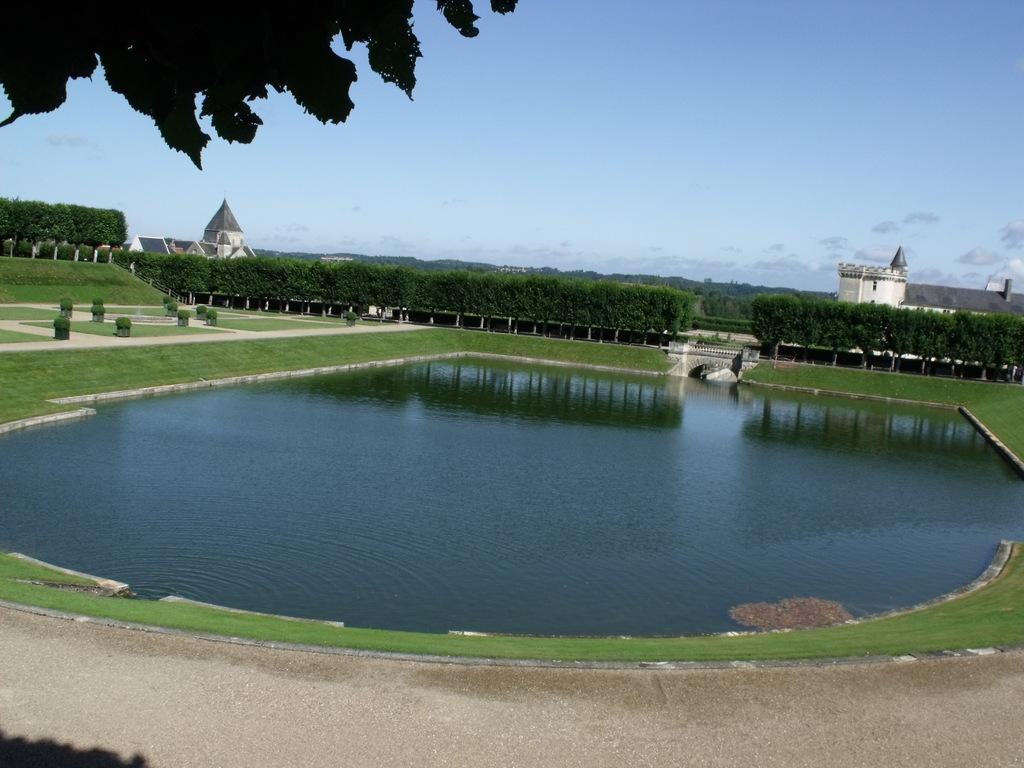What type of outdoor space is depicted in the image? There is a garden in the image. Are there any specific features within the garden? Yes, there is a pond in the garden. What can be seen in the background of the image? The background of the image includes a blue sky. What type of island can be seen in the pond in the image? There is no island present in the pond in the image. What is the aftermath of the storm in the image? There is no storm or any indication of an aftermath in the image; it features a garden with a pond and a blue sky. 